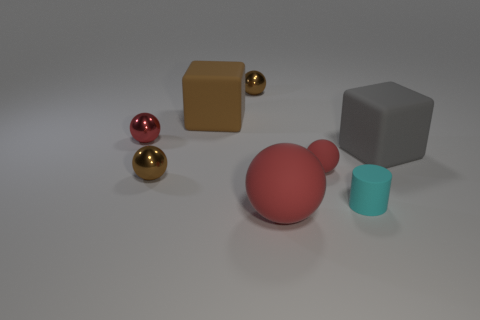What number of brown objects have the same size as the gray object?
Your response must be concise. 1. There is a large matte thing that is in front of the brown shiny thing in front of the large brown rubber cube; what shape is it?
Give a very brief answer. Sphere. Is the number of brown metallic balls less than the number of big brown things?
Your answer should be compact. No. The large block that is to the left of the small cylinder is what color?
Your answer should be very brief. Brown. There is a big object that is both behind the small cyan cylinder and to the left of the gray cube; what material is it?
Your answer should be very brief. Rubber. There is a big red object that is the same material as the cyan cylinder; what is its shape?
Provide a short and direct response. Sphere. There is a sphere that is to the right of the big red matte object; what number of red rubber spheres are in front of it?
Ensure brevity in your answer.  1. How many big matte objects are both left of the big gray block and behind the small matte cylinder?
Provide a short and direct response. 1. What number of other objects are the same material as the large brown block?
Your answer should be very brief. 4. The cube that is on the left side of the cyan object behind the big red matte object is what color?
Your answer should be compact. Brown. 